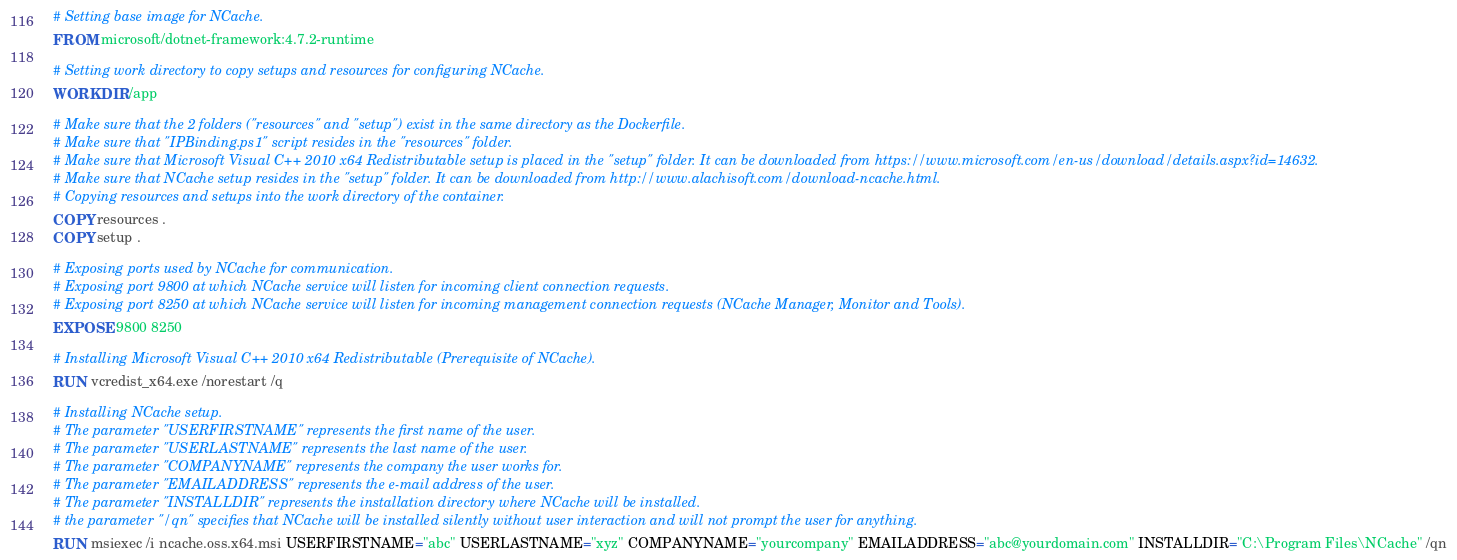<code> <loc_0><loc_0><loc_500><loc_500><_Dockerfile_># Setting base image for NCache.
FROM microsoft/dotnet-framework:4.7.2-runtime

# Setting work directory to copy setups and resources for configuring NCache.
WORKDIR /app

# Make sure that the 2 folders ("resources" and "setup") exist in the same directory as the Dockerfile.
# Make sure that "IPBinding.ps1" script resides in the "resources" folder.
# Make sure that Microsoft Visual C++ 2010 x64 Redistributable setup is placed in the "setup" folder. It can be downloaded from https://www.microsoft.com/en-us/download/details.aspx?id=14632.
# Make sure that NCache setup resides in the "setup" folder. It can be downloaded from http://www.alachisoft.com/download-ncache.html.
# Copying resources and setups into the work directory of the container.
COPY resources .
COPY setup .

# Exposing ports used by NCache for communication.
# Exposing port 9800 at which NCache service will listen for incoming client connection requests.
# Exposing port 8250 at which NCache service will listen for incoming management connection requests (NCache Manager, Monitor and Tools).
EXPOSE 9800 8250 

# Installing Microsoft Visual C++ 2010 x64 Redistributable (Prerequisite of NCache).
RUN vcredist_x64.exe /norestart /q

# Installing NCache setup.
# The parameter "USERFIRSTNAME" represents the first name of the user.
# The parameter "USERLASTNAME" represents the last name of the user.
# The parameter "COMPANYNAME" represents the company the user works for.
# The parameter "EMAILADDRESS" represents the e-mail address of the user.
# The parameter "INSTALLDIR" represents the installation directory where NCache will be installed.
# the parameter "/qn" specifies that NCache will be installed silently without user interaction and will not prompt the user for anything.
RUN msiexec /i ncache.oss.x64.msi USERFIRSTNAME="abc" USERLASTNAME="xyz" COMPANYNAME="yourcompany" EMAILADDRESS="abc@yourdomain.com" INSTALLDIR="C:\Program Files\NCache" /qn
</code> 